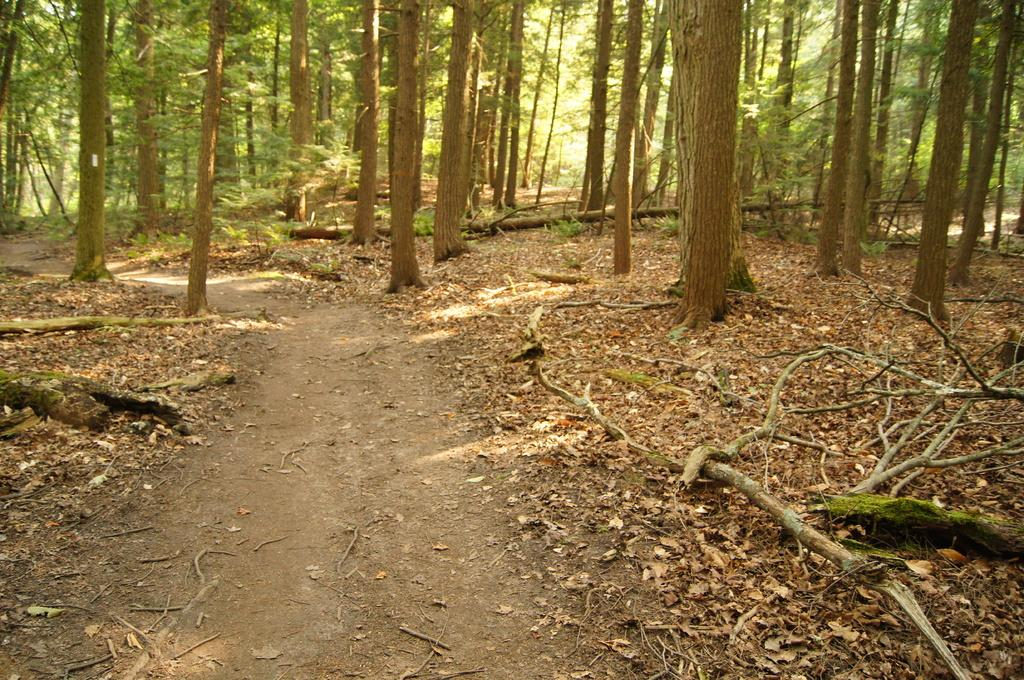What type of environment is shown in the image? The image depicts a forest area. Is there any specific feature in the forest area? Yes, there is a path in the forest area. What can be seen on the path? Dried leaves are present on the path. What can be seen in the background of the image? There are many trees visible in the background. Can you see a yoke being used by someone in the forest area? There is no yoke or anyone using it present in the image. How does the father interact with the trees in the image? There is no father or any person present in the image, so it is not possible to determine how they might interact with the trees. 